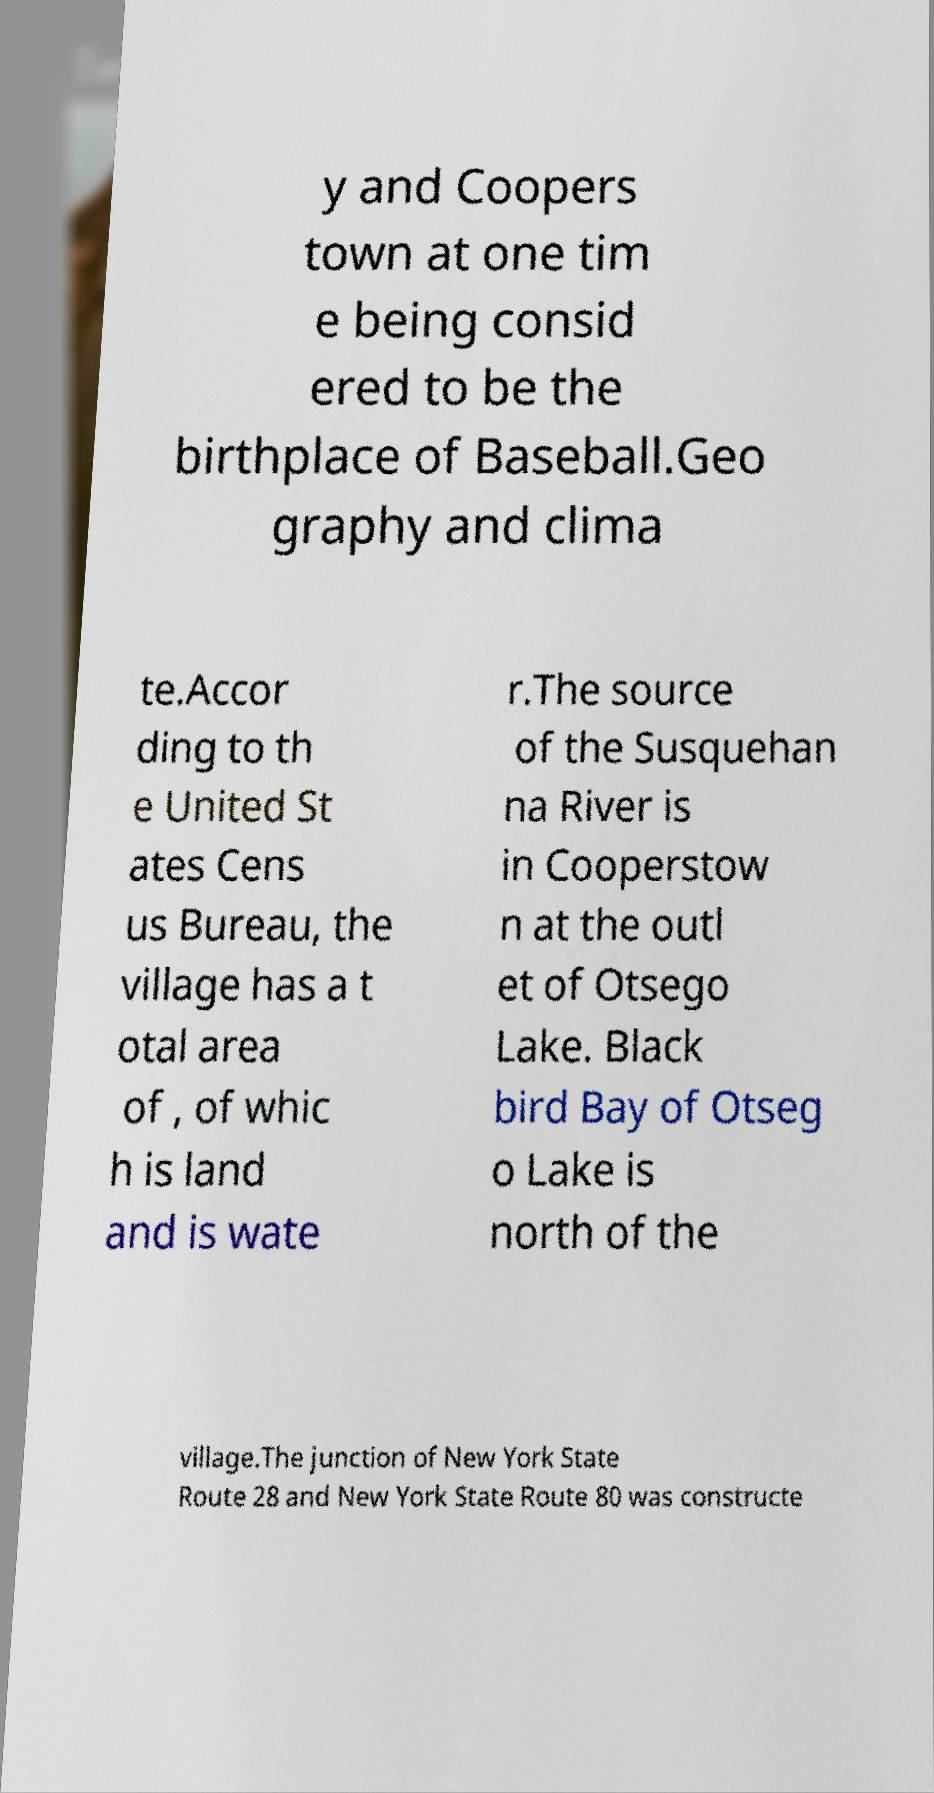For documentation purposes, I need the text within this image transcribed. Could you provide that? y and Coopers town at one tim e being consid ered to be the birthplace of Baseball.Geo graphy and clima te.Accor ding to th e United St ates Cens us Bureau, the village has a t otal area of , of whic h is land and is wate r.The source of the Susquehan na River is in Cooperstow n at the outl et of Otsego Lake. Black bird Bay of Otseg o Lake is north of the village.The junction of New York State Route 28 and New York State Route 80 was constructe 